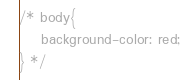Convert code to text. <code><loc_0><loc_0><loc_500><loc_500><_CSS_>/* body{
    background-color: red;
} */</code> 